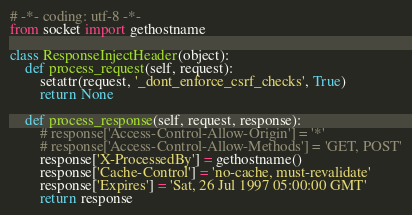<code> <loc_0><loc_0><loc_500><loc_500><_Python_># -*- coding: utf-8 -*- 
from socket import gethostname

class ResponseInjectHeader(object):
    def process_request(self, request):
        setattr(request, '_dont_enforce_csrf_checks', True)
        return None

    def process_response(self, request, response):
        # response['Access-Control-Allow-Origin'] = '*'
        # response['Access-Control-Allow-Methods'] = 'GET, POST'
        response['X-ProcessedBy'] = gethostname()
        response['Cache-Control'] = 'no-cache, must-revalidate'
        response['Expires'] = 'Sat, 26 Jul 1997 05:00:00 GMT'
        return response</code> 